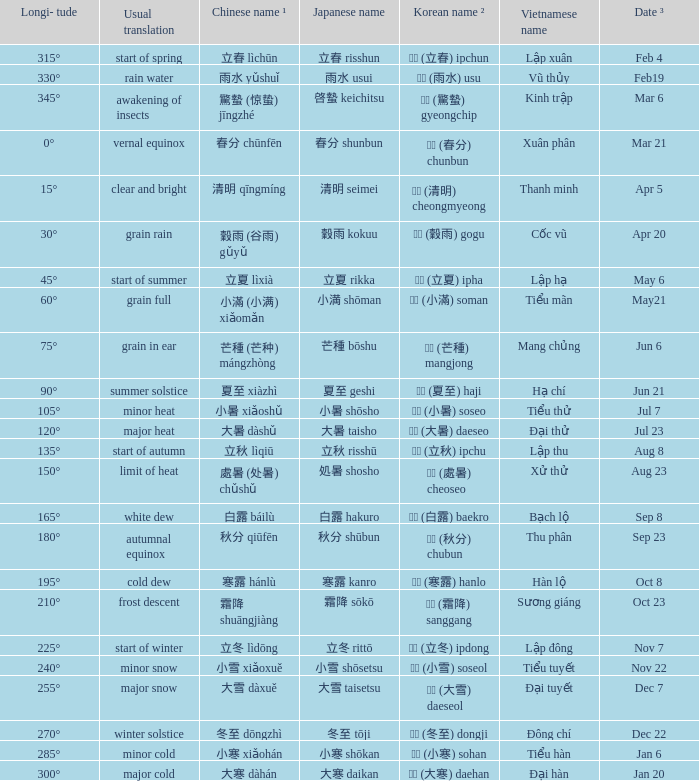On the 6th of june, what longitude is observed? 75°. 